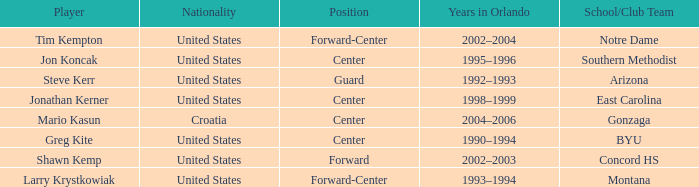What nationality has jon koncak as the player? United States. 